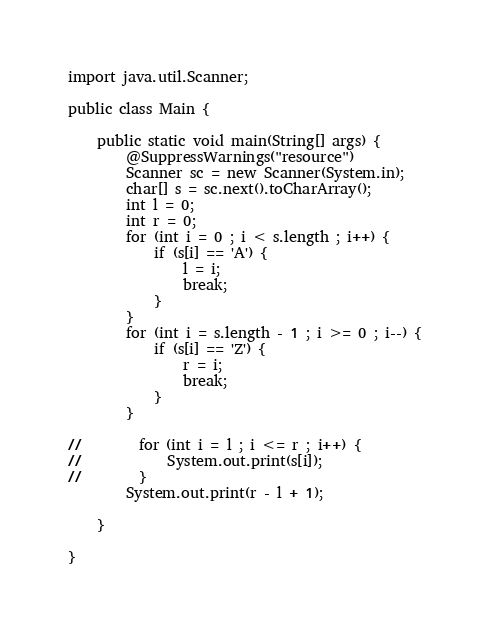Convert code to text. <code><loc_0><loc_0><loc_500><loc_500><_Java_>import java.util.Scanner;

public class Main {

    public static void main(String[] args) {
        @SuppressWarnings("resource")
        Scanner sc = new Scanner(System.in);
        char[] s = sc.next().toCharArray();
        int l = 0;
        int r = 0;
        for (int i = 0 ; i < s.length ; i++) {
            if (s[i] == 'A') {
                l = i;
                break;
            }
        }
        for (int i = s.length - 1 ; i >= 0 ; i--) {
            if (s[i] == 'Z') {
                r = i;
                break;
            }
        }

//        for (int i = l ; i <= r ; i++) {
//            System.out.print(s[i]);
//        }
        System.out.print(r - l + 1);

    }

}</code> 